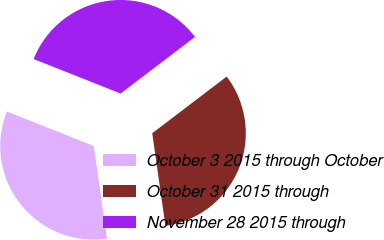Convert chart to OTSL. <chart><loc_0><loc_0><loc_500><loc_500><pie_chart><fcel>October 3 2015 through October<fcel>October 31 2015 through<fcel>November 28 2015 through<nl><fcel>33.27%<fcel>33.1%<fcel>33.63%<nl></chart> 